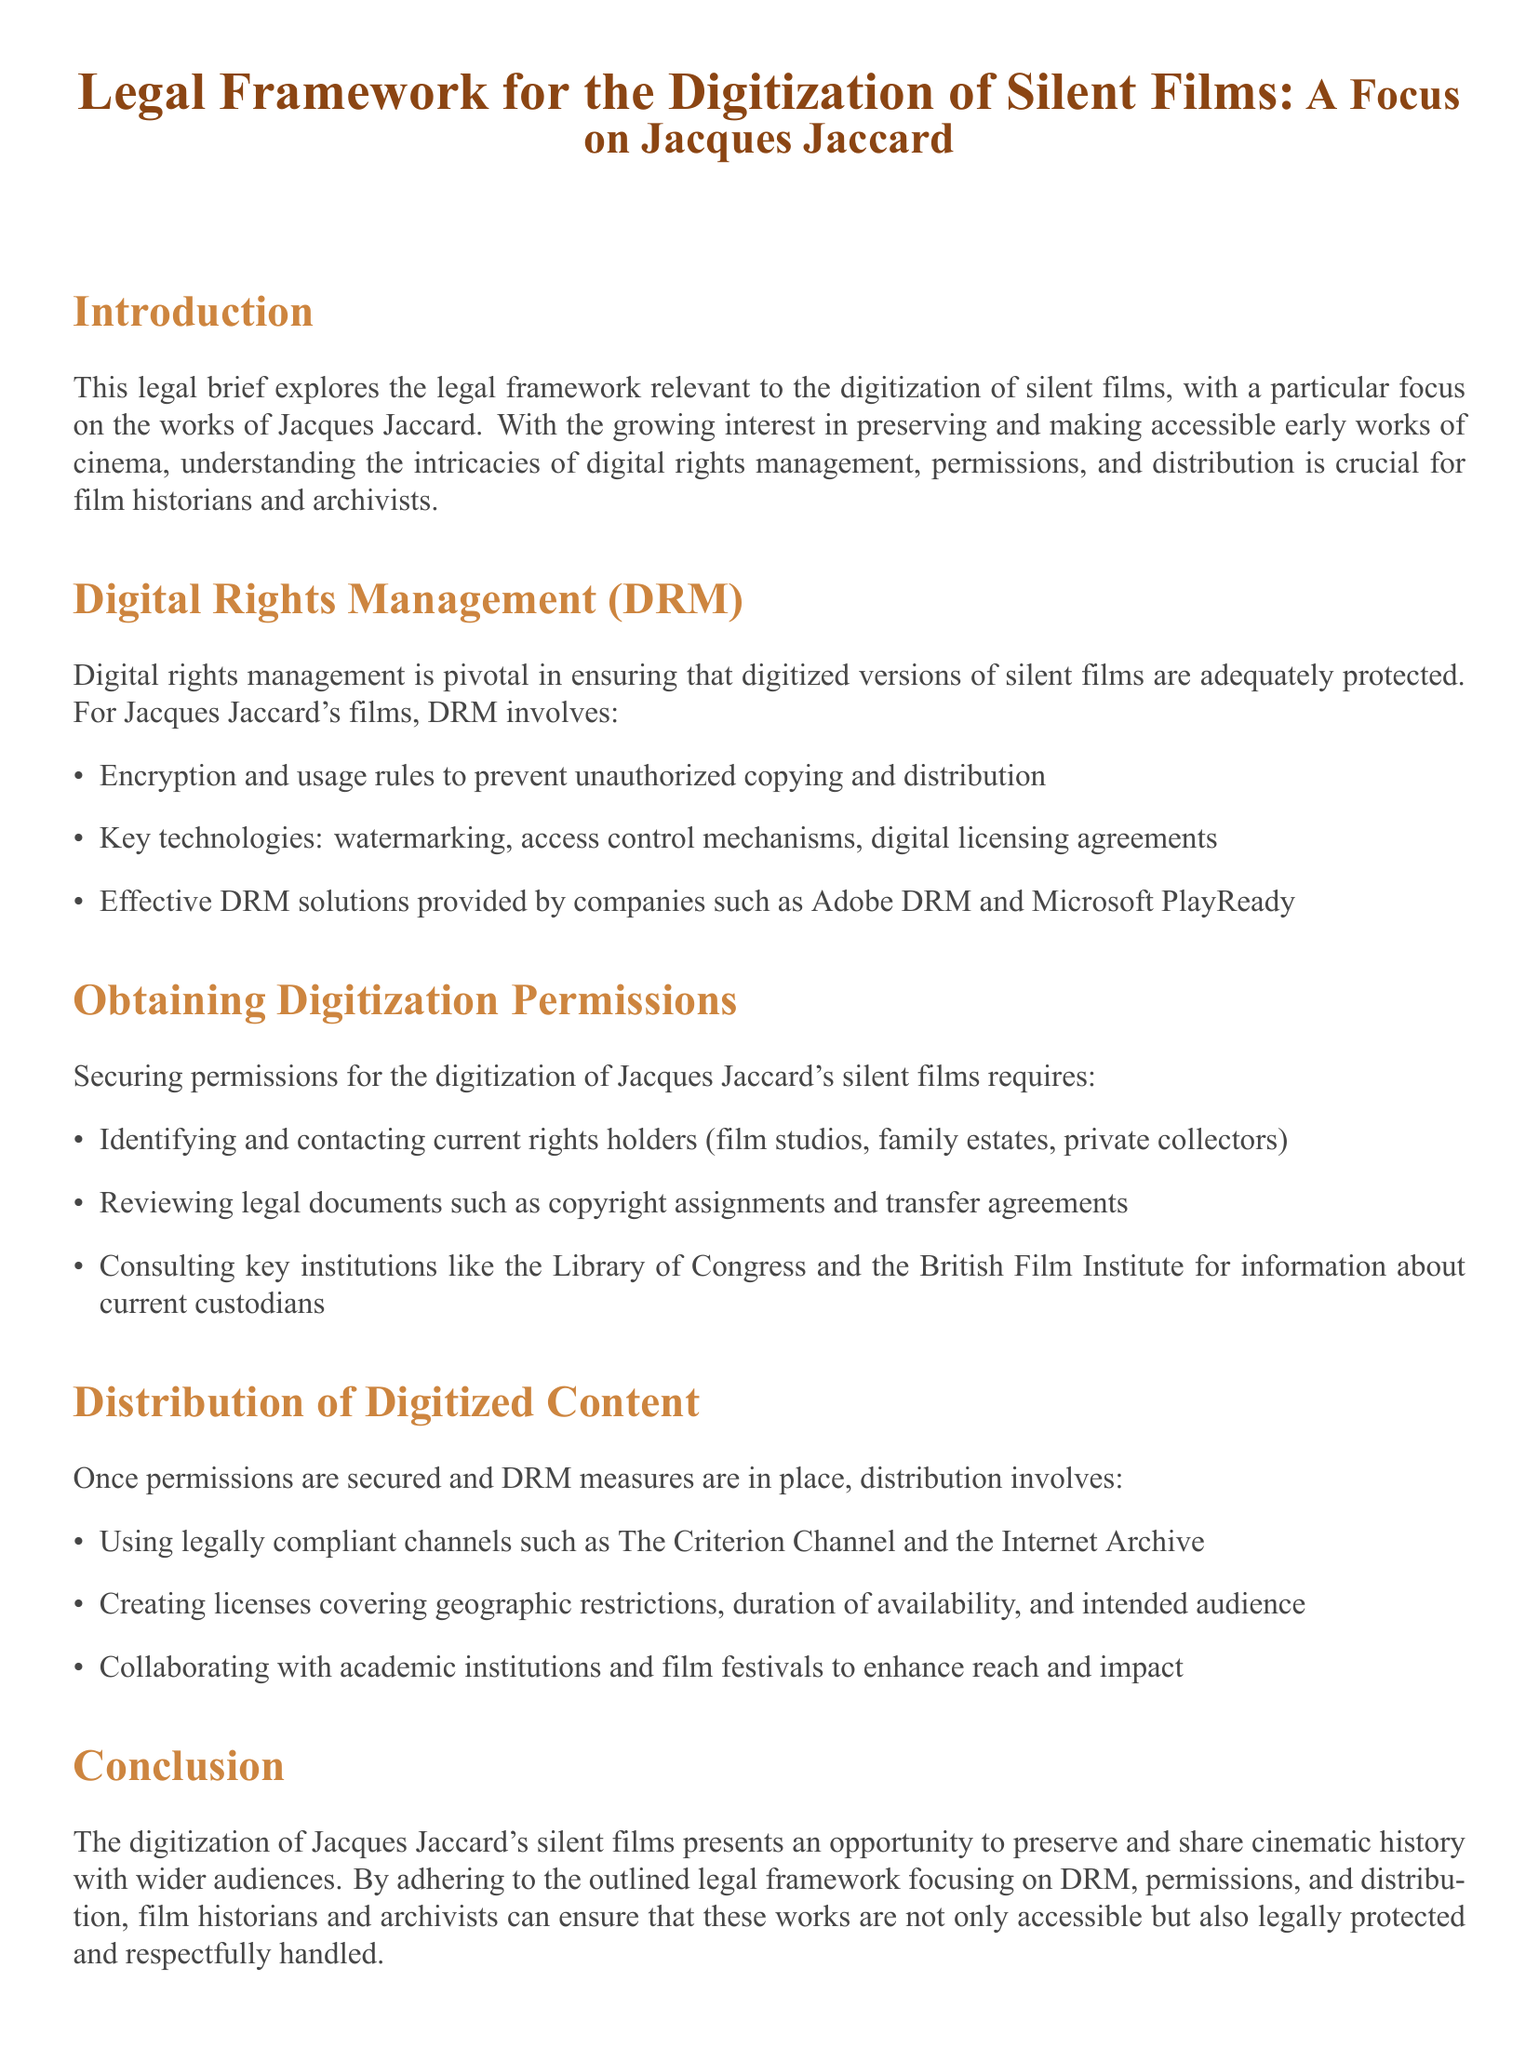What is the focus of the legal brief? The legal brief focuses on the legal framework for the digitization of silent films, particularly Jacques Jaccard's works.
Answer: Jacques Jaccard What does DRM stand for in the context of this document? DRM refers to digital rights management, which is crucial for protecting digitized films.
Answer: digital rights management What technology is mentioned as a DRM solution? The document lists specific technologies used in DRM solutions for protecting films.
Answer: Adobe DRM Which institutions are suggested for consulting about current custodians? The brief suggests reaching out to key repositories for historical film information.
Answer: Library of Congress and the British Film Institute What kinds of channels are suggested for distribution of digitized content? The document indicates specific platforms where digitized films can be legally distributed.
Answer: The Criterion Channel and the Internet Archive What is one aspect of permissions for digitization? The process of obtaining permissions involves contacting specific individuals or groups related to rights.
Answer: Identifying and contacting current rights holders How does the document characterize the opportunity of digitizing Jacques Jaccard's films? The brief ends with a positive note on the potential impact of digitization efforts.
Answer: Preserve and share cinematic history What is the main objective in establishing a legal framework for digitization? The brief emphasizes a structured approach to ensure legal compliance and protect rights.
Answer: Ensure accessibility and legal protection 